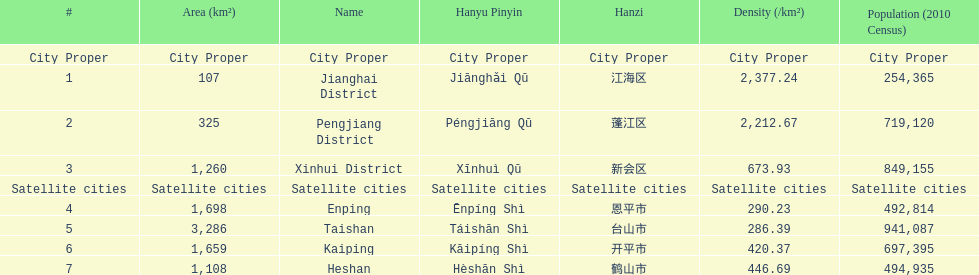What cities are there in jiangmen? Jianghai District, Pengjiang District, Xinhui District, Enping, Taishan, Kaiping, Heshan. Of those, which ones are a city proper? Jianghai District, Pengjiang District, Xinhui District. Of those, which one has the smallest area in km2? Jianghai District. 